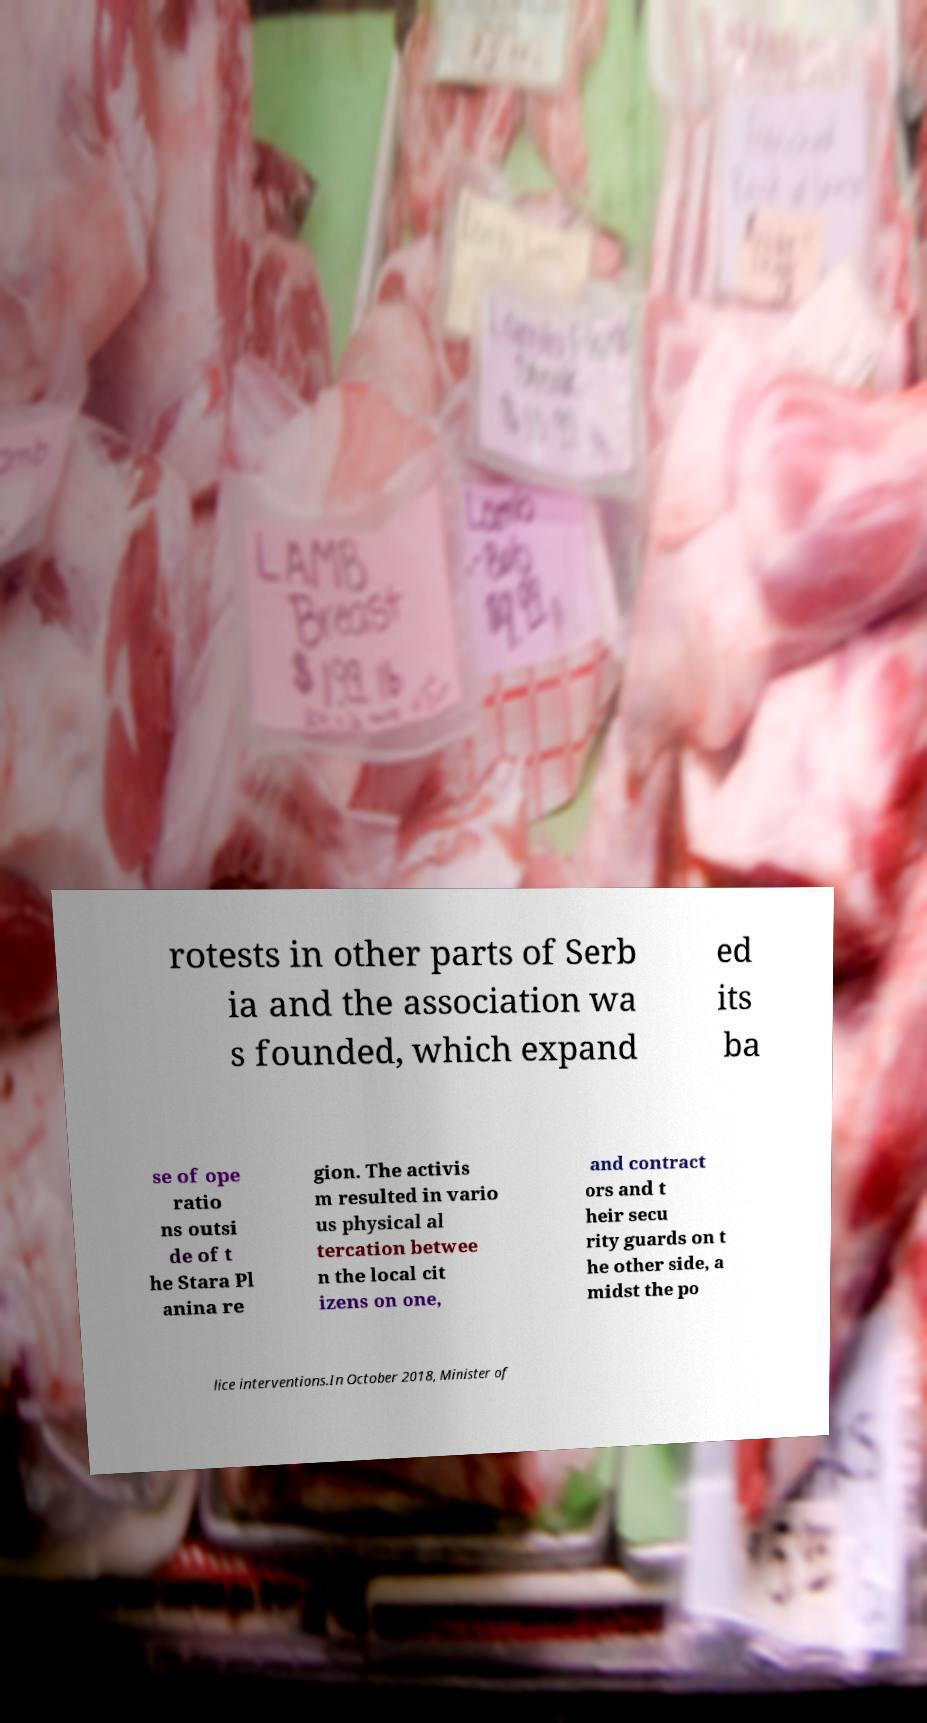Please read and relay the text visible in this image. What does it say? rotests in other parts of Serb ia and the association wa s founded, which expand ed its ba se of ope ratio ns outsi de of t he Stara Pl anina re gion. The activis m resulted in vario us physical al tercation betwee n the local cit izens on one, and contract ors and t heir secu rity guards on t he other side, a midst the po lice interventions.In October 2018, Minister of 